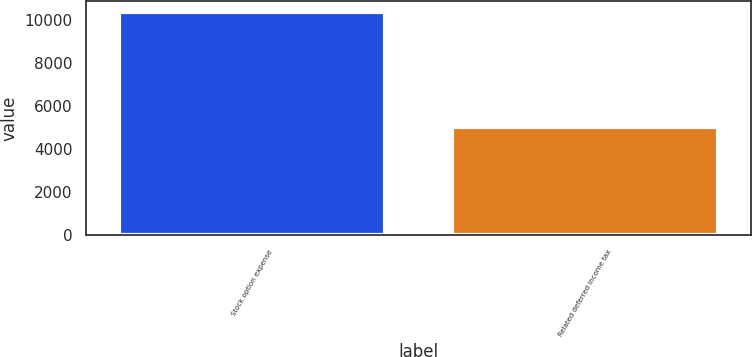<chart> <loc_0><loc_0><loc_500><loc_500><bar_chart><fcel>Stock option expense<fcel>Related deferred income tax<nl><fcel>10369<fcel>5021<nl></chart> 